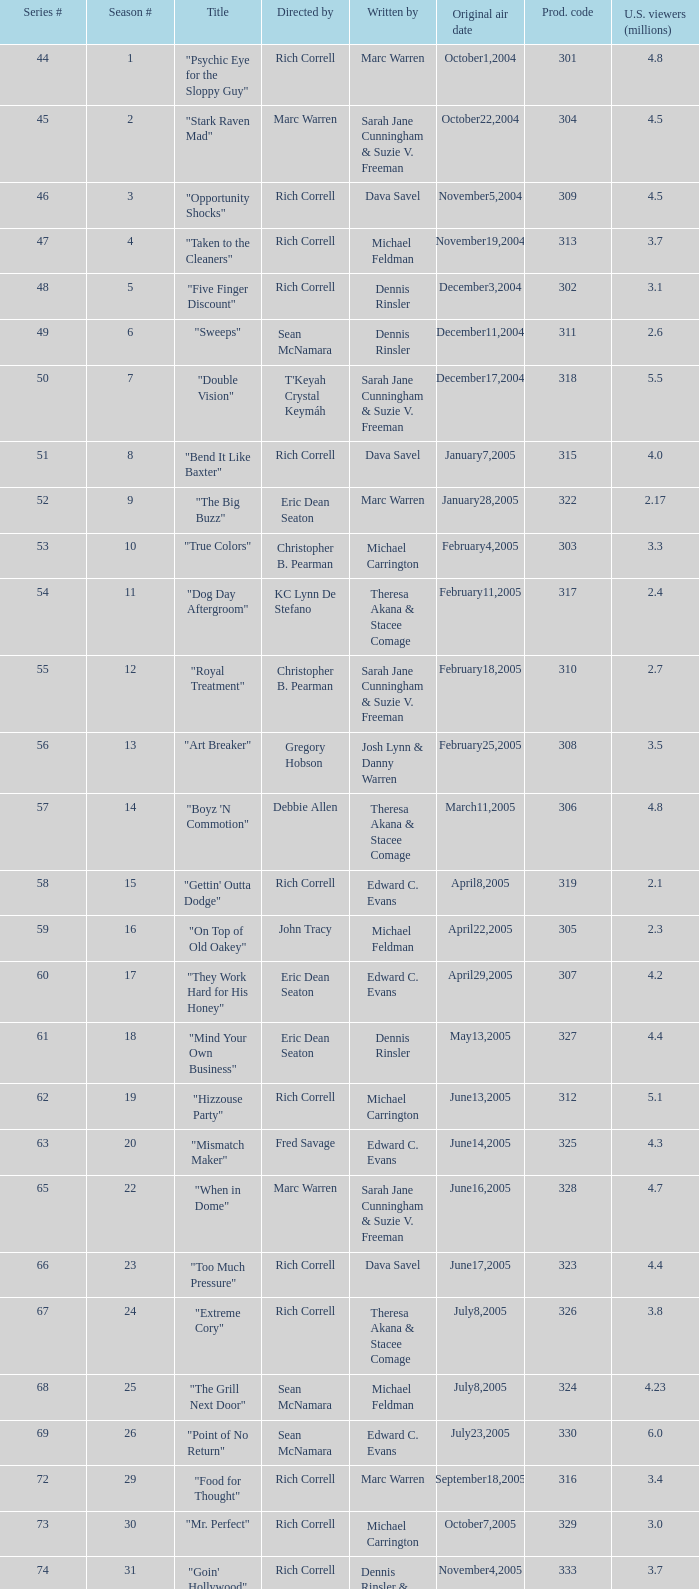Which episode number of the season had the title "vision impossible"? 34.0. 